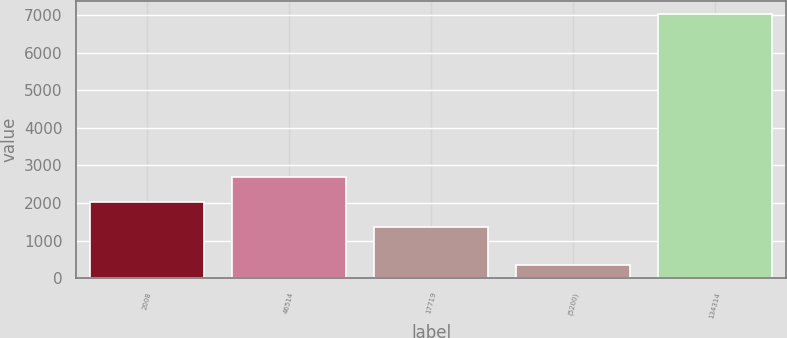Convert chart. <chart><loc_0><loc_0><loc_500><loc_500><bar_chart><fcel>2008<fcel>46514<fcel>17719<fcel>(5200)<fcel>134314<nl><fcel>2036.81<fcel>2704.02<fcel>1369.6<fcel>353.7<fcel>7025.8<nl></chart> 